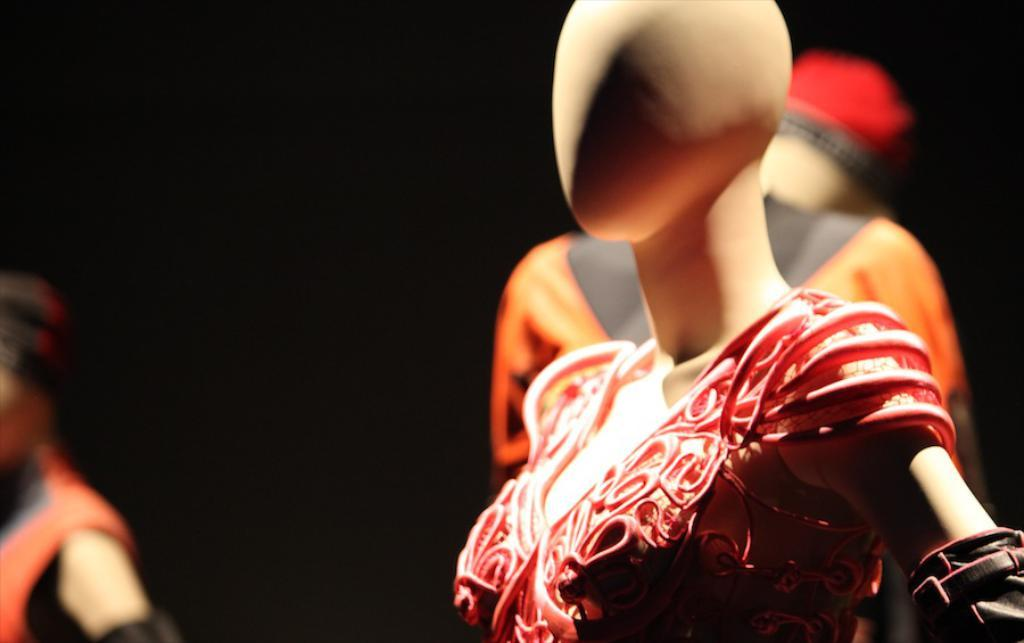What are the main subjects in the image? There are mannequins in the image. What can be observed about the background of the image? The background of the image is dark. Can you tell me how many dolls are being lifted by the stranger in the image? There is no stranger or dolls present in the image; it features mannequins against a dark background. 